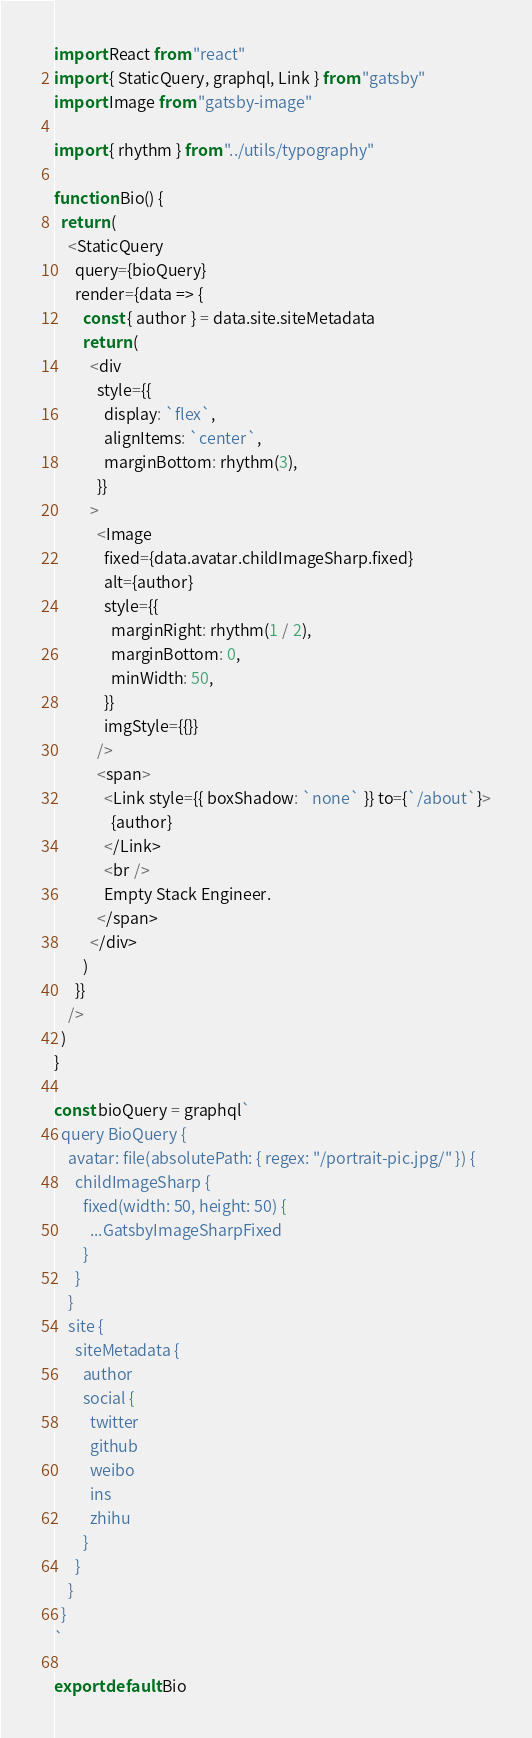Convert code to text. <code><loc_0><loc_0><loc_500><loc_500><_JavaScript_>import React from "react"
import { StaticQuery, graphql, Link } from "gatsby"
import Image from "gatsby-image"

import { rhythm } from "../utils/typography"

function Bio() {
  return (
    <StaticQuery
      query={bioQuery}
      render={data => {
        const { author } = data.site.siteMetadata
        return (
          <div
            style={{
              display: `flex`,
              alignItems: `center`,
              marginBottom: rhythm(3),
            }}
          >
            <Image
              fixed={data.avatar.childImageSharp.fixed}
              alt={author}
              style={{
                marginRight: rhythm(1 / 2),
                marginBottom: 0,
                minWidth: 50,
              }}
              imgStyle={{}}
            />
            <span>
              <Link style={{ boxShadow: `none` }} to={`/about`}>
                {author}
              </Link>
              <br />
              Empty Stack Engineer.
            </span>
          </div>
        )
      }}
    />
  )
}

const bioQuery = graphql`
  query BioQuery {
    avatar: file(absolutePath: { regex: "/portrait-pic.jpg/" }) {
      childImageSharp {
        fixed(width: 50, height: 50) {
          ...GatsbyImageSharpFixed
        }
      }
    }
    site {
      siteMetadata {
        author
        social {
          twitter
          github
          weibo
          ins
          zhihu
        }
      }
    }
  }
`

export default Bio
</code> 